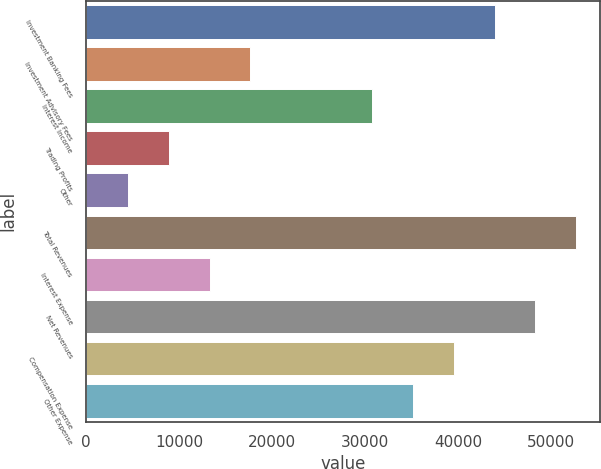Convert chart. <chart><loc_0><loc_0><loc_500><loc_500><bar_chart><fcel>Investment Banking Fees<fcel>Investment Advisory Fees<fcel>Interest Income<fcel>Trading Profits<fcel>Other<fcel>Total Revenues<fcel>Interest Expense<fcel>Net Revenues<fcel>Compensation Expense<fcel>Other Expense<nl><fcel>43924<fcel>17645.2<fcel>30784.6<fcel>8885.6<fcel>4505.8<fcel>52683.6<fcel>13265.4<fcel>48303.8<fcel>39544.2<fcel>35164.4<nl></chart> 